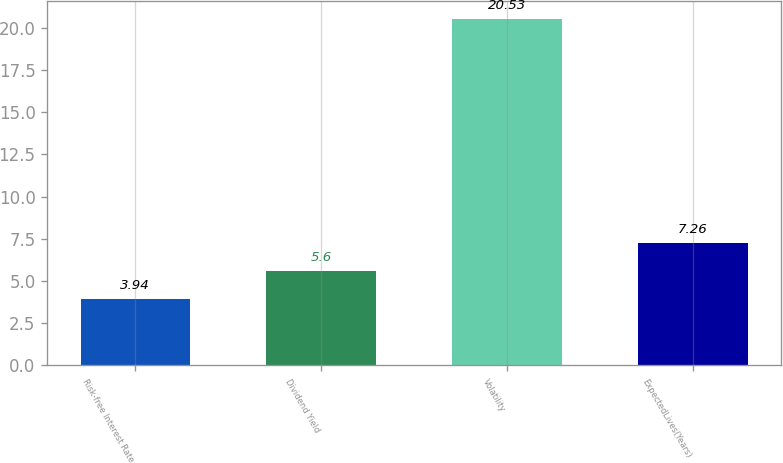Convert chart. <chart><loc_0><loc_0><loc_500><loc_500><bar_chart><fcel>Risk-free Interest Rate<fcel>Dividend Yield<fcel>Volatility<fcel>ExpectedLives(Years)<nl><fcel>3.94<fcel>5.6<fcel>20.53<fcel>7.26<nl></chart> 